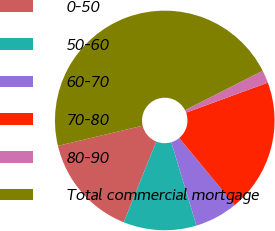Convert chart. <chart><loc_0><loc_0><loc_500><loc_500><pie_chart><fcel>0-50<fcel>50-60<fcel>60-70<fcel>70-80<fcel>80-90<fcel>Total commercial mortgage<nl><fcel>15.19%<fcel>10.75%<fcel>6.32%<fcel>19.62%<fcel>1.88%<fcel>46.23%<nl></chart> 